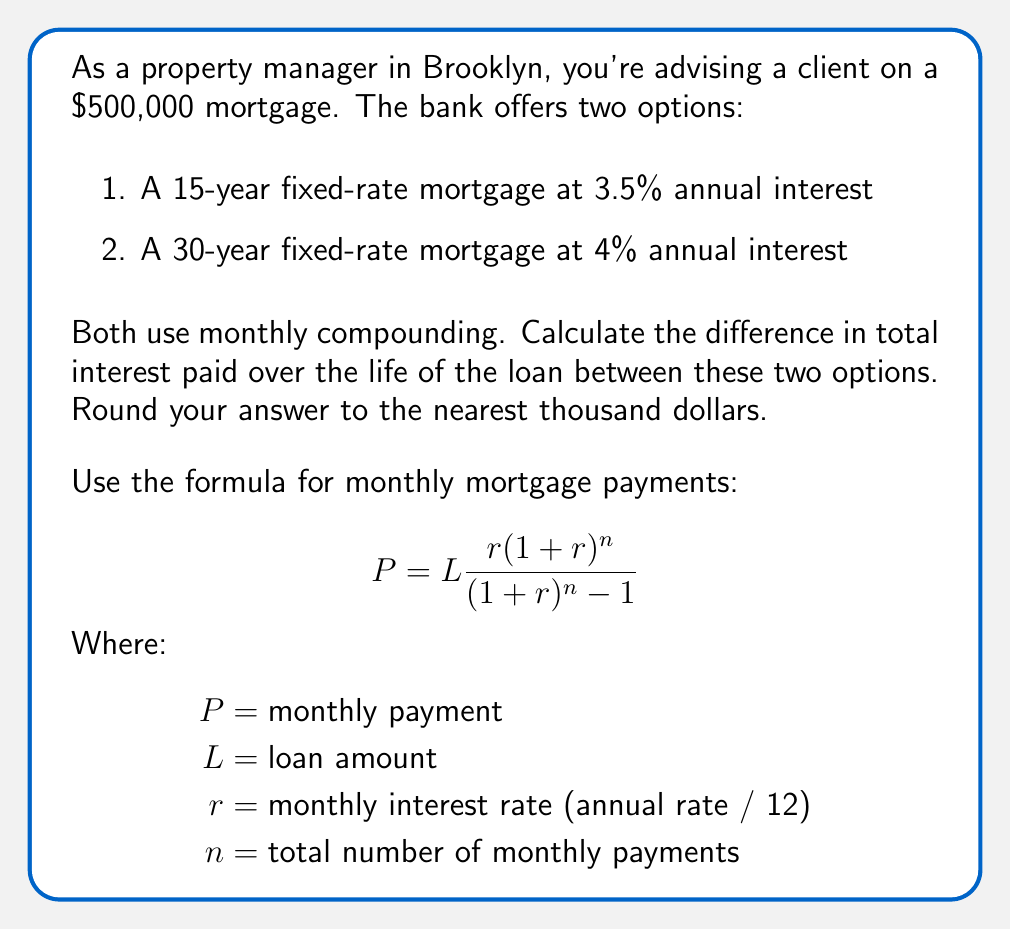Provide a solution to this math problem. Let's approach this step-by-step:

1) First, calculate the monthly payments for each option:

   For 15-year mortgage:
   $r = 0.035 / 12 = 0.002917$
   $n = 15 * 12 = 180$
   
   $$P_{15} = 500000 \frac{0.002917(1+0.002917)^{180}}{(1+0.002917)^{180} - 1} = 3,572.38$$

   For 30-year mortgage:
   $r = 0.04 / 12 = 0.003333$
   $n = 30 * 12 = 360$
   
   $$P_{30} = 500000 \frac{0.003333(1+0.003333)^{360}}{(1+0.003333)^{360} - 1} = 2,387.08$$

2) Now, calculate the total amount paid over the life of each loan:

   15-year: $3,572.38 * 180 = 643,028.40$
   30-year: $2,387.08 * 360 = 859,348.80$

3) Subtract the original loan amount to get the total interest paid:

   15-year: $643,028.40 - 500,000 = 143,028.40$
   30-year: $859,348.80 - 500,000 = 359,348.80$

4) Calculate the difference in total interest paid:

   $359,348.80 - 143,028.40 = 216,320.40$

5) Round to the nearest thousand:

   $216,320.40 ≈ 216,000$
Answer: $216,000 